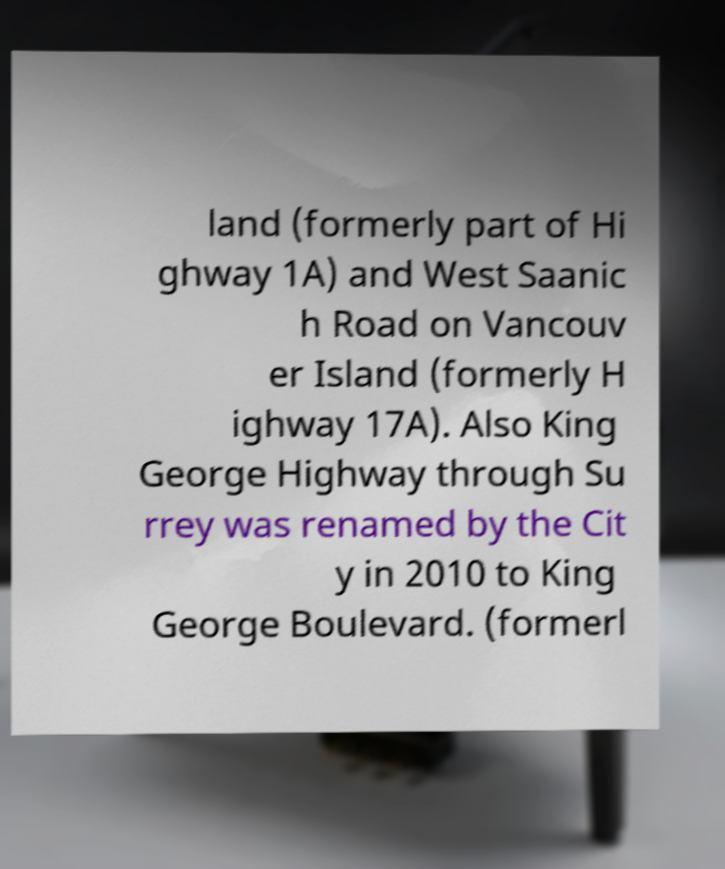Can you read and provide the text displayed in the image?This photo seems to have some interesting text. Can you extract and type it out for me? land (formerly part of Hi ghway 1A) and West Saanic h Road on Vancouv er Island (formerly H ighway 17A). Also King George Highway through Su rrey was renamed by the Cit y in 2010 to King George Boulevard. (formerl 